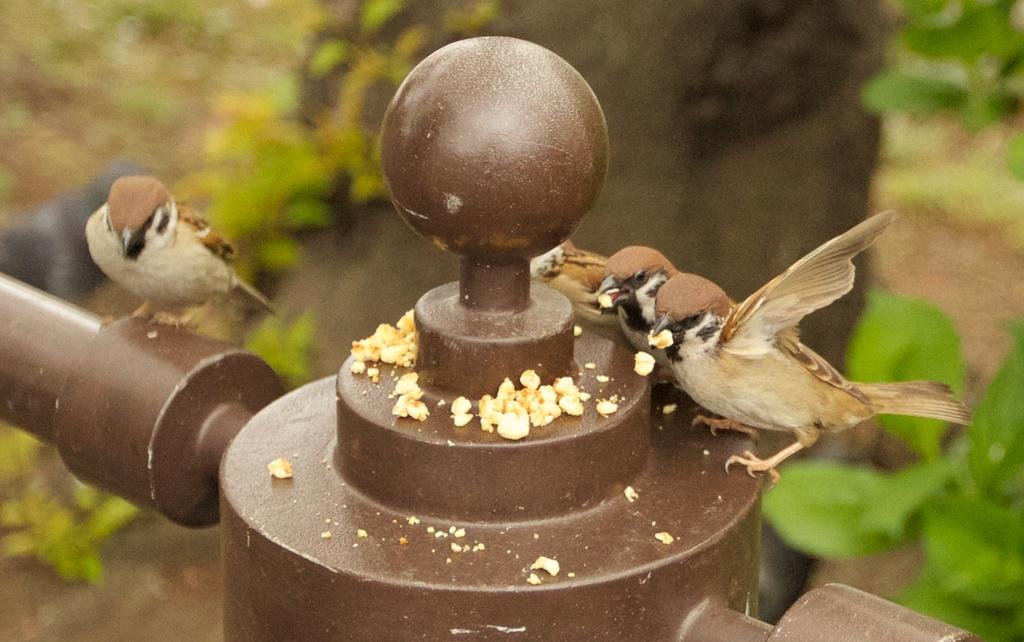What is the main subject of the image? The main subject of the image is birds. Where are the birds located in the image? The birds are in the center of the image. What is present on the pole in the image? There is food on a pole in the image. What can be seen in the background of the image? There are trees in the background of the image. What type of joke can be seen being told by the geese in the image? There are no geese present in the image, and therefore no jokes can be seen being told by them. Can you describe the act of smashing the birds in the image? There is no act of smashing the birds in the image; the birds are simply present in the center. 